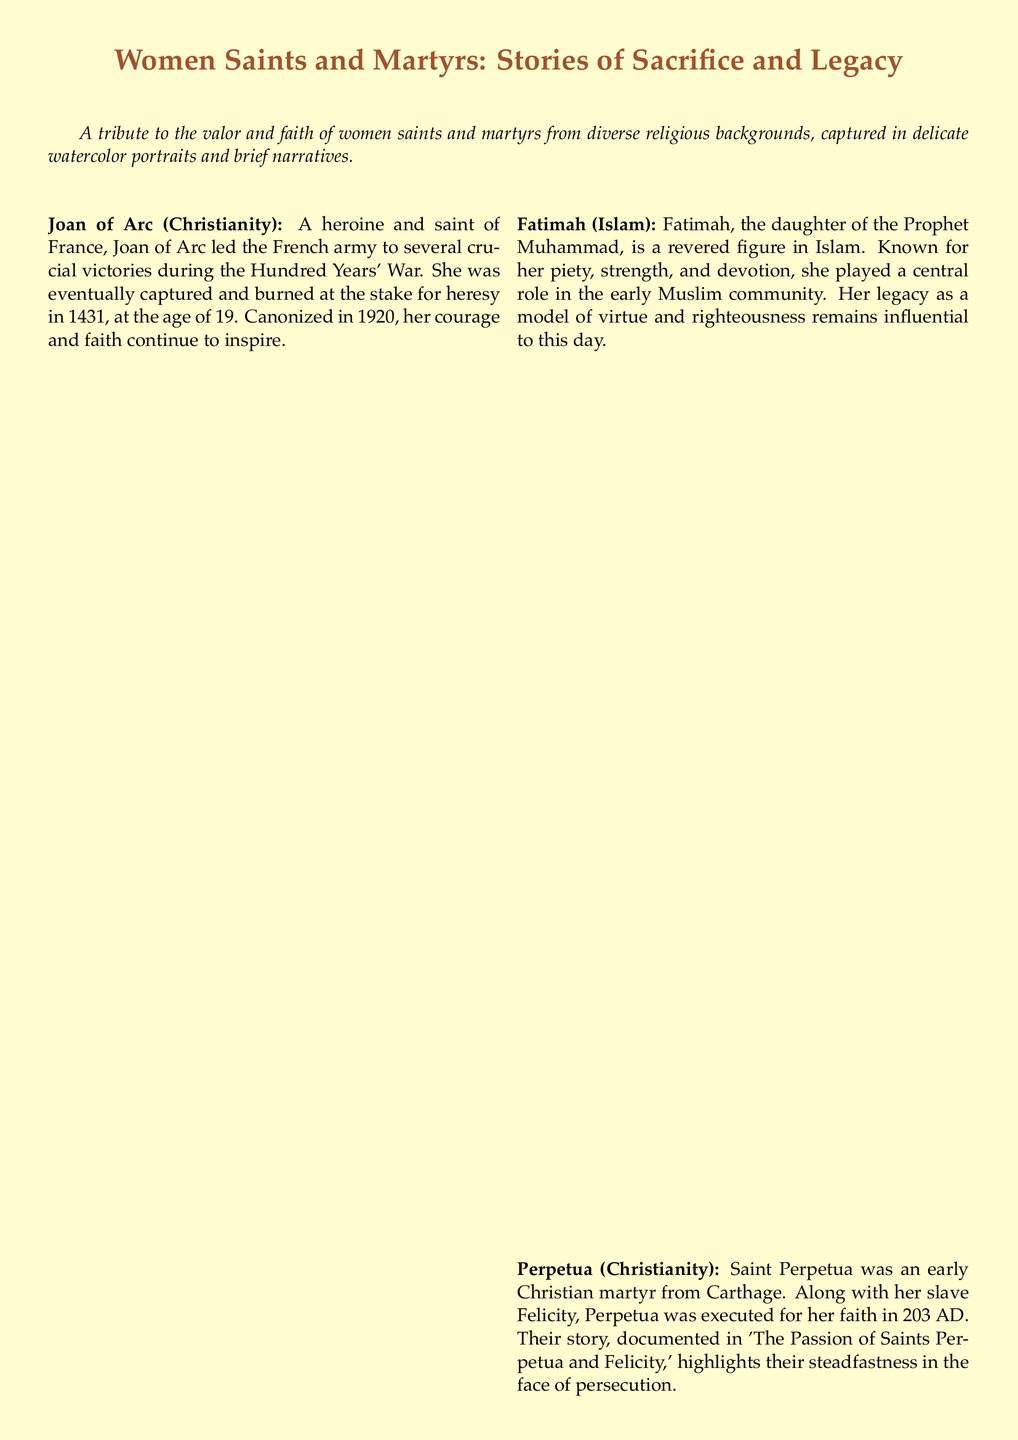What is the title of the tribute card? The title of the tribute card is presented prominently at the top of the document.
Answer: Women Saints and Martyrs: Stories of Sacrifice and Legacy Who was captured and burned at the stake? This information refers to a specific individual mentioned in the document known for her victories during a war.
Answer: Joan of Arc In what year was Joan of Arc canonized? The document specifies the canonization year of Joan of Arc, providing a clear historical reference.
Answer: 1920 What role did Fatimah play in her community? The document summarizes her significance in the early Muslim community.
Answer: Central role What is Mahalakshmi known for in Hinduism? The card describes Mahalakshmi's attributes related to wealth and prosperity.
Answer: Goddess of wealth, prosperity, and purity How did Makino Tomika demonstrate her faith? This refers to her actions during religious persecution, highlighting her commitment to her beliefs.
Answer: Refused to renounce her faith How many women saints and martyrs are featured in the document? The total number of women saints and martyrs can be counted based on the provided descriptions.
Answer: Five What narrative style is used to describe the saints and martyrs? The descriptions of the figures are given in a particular way, denoting short, impactful accounts.
Answer: Succinct summaries What medium is used for the portraits in the card? The document specifically mentions the artistic style used for the portraits accompanying the narratives.
Answer: Watercolor 